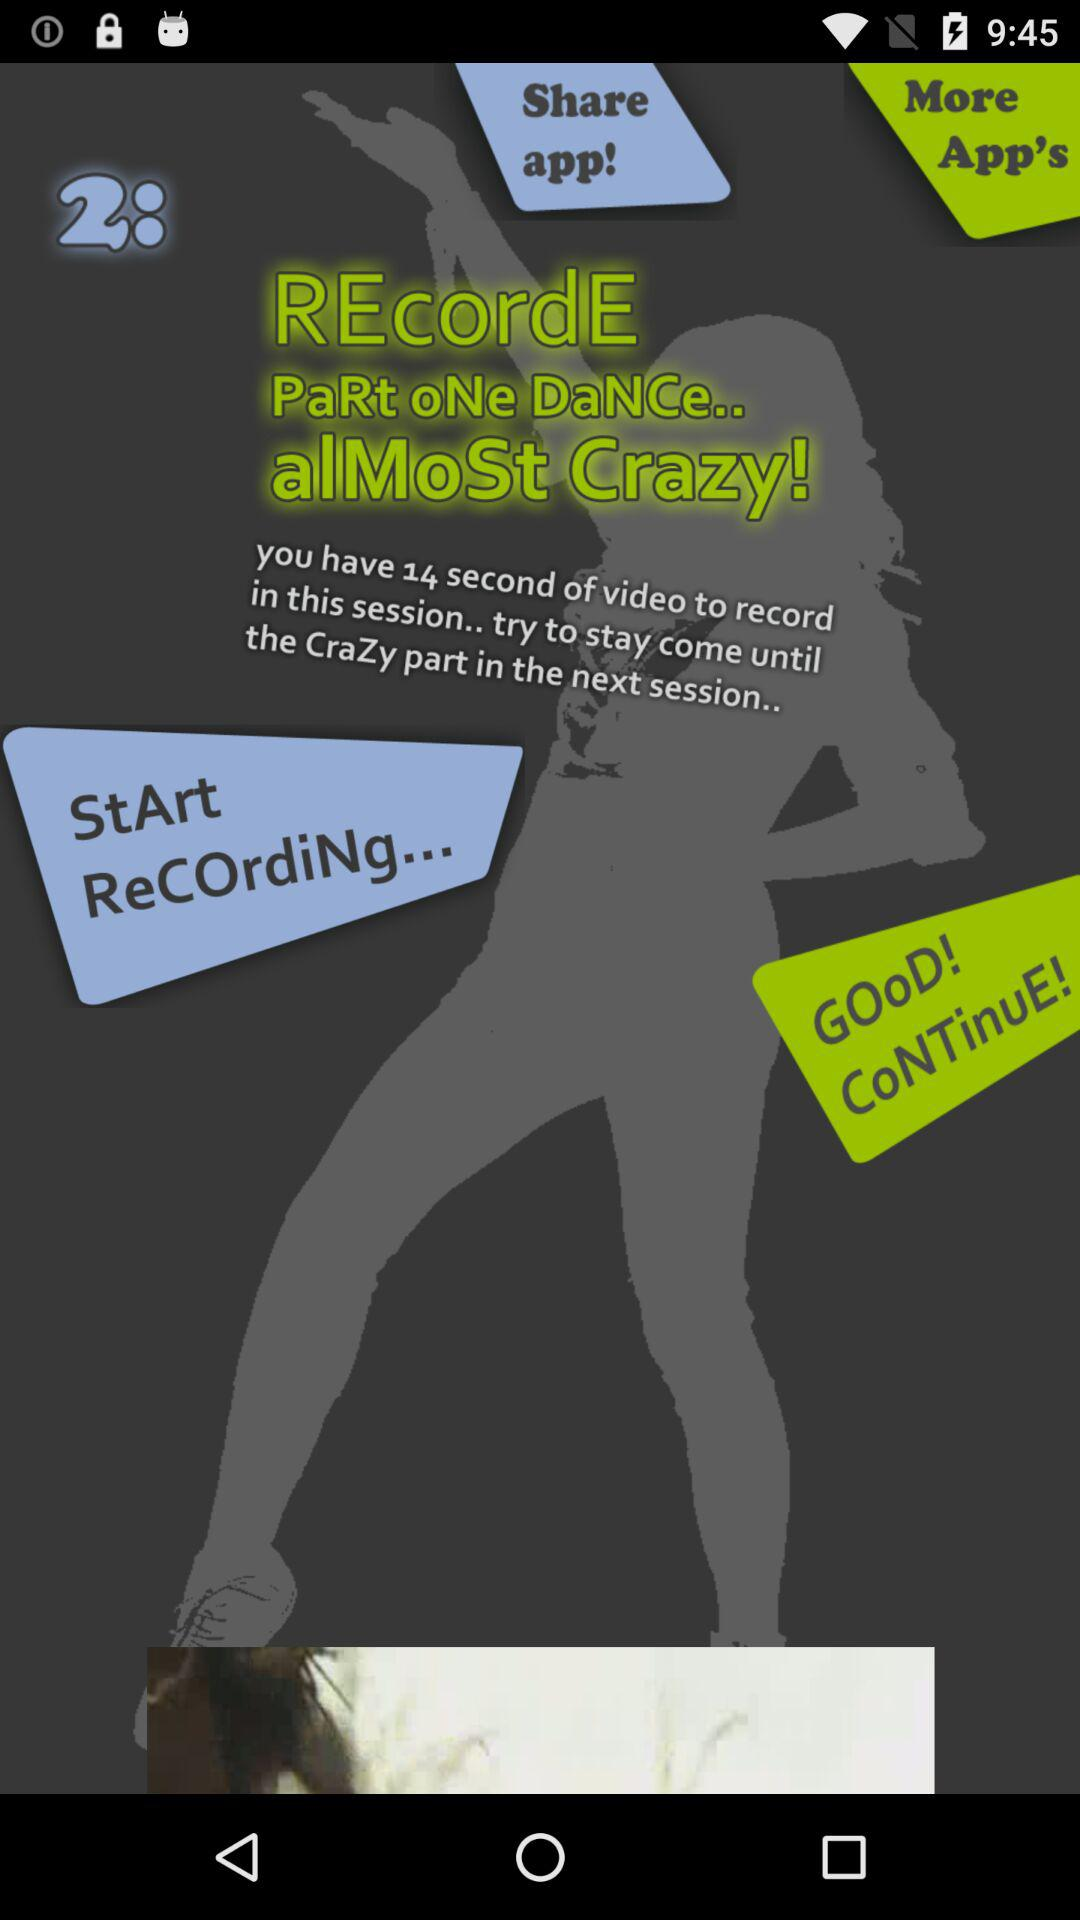How many more seconds do I have to record?
Answer the question using a single word or phrase. 14 